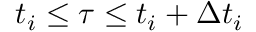<formula> <loc_0><loc_0><loc_500><loc_500>t _ { i } \leq \tau \leq t _ { i } + \Delta t _ { i }</formula> 